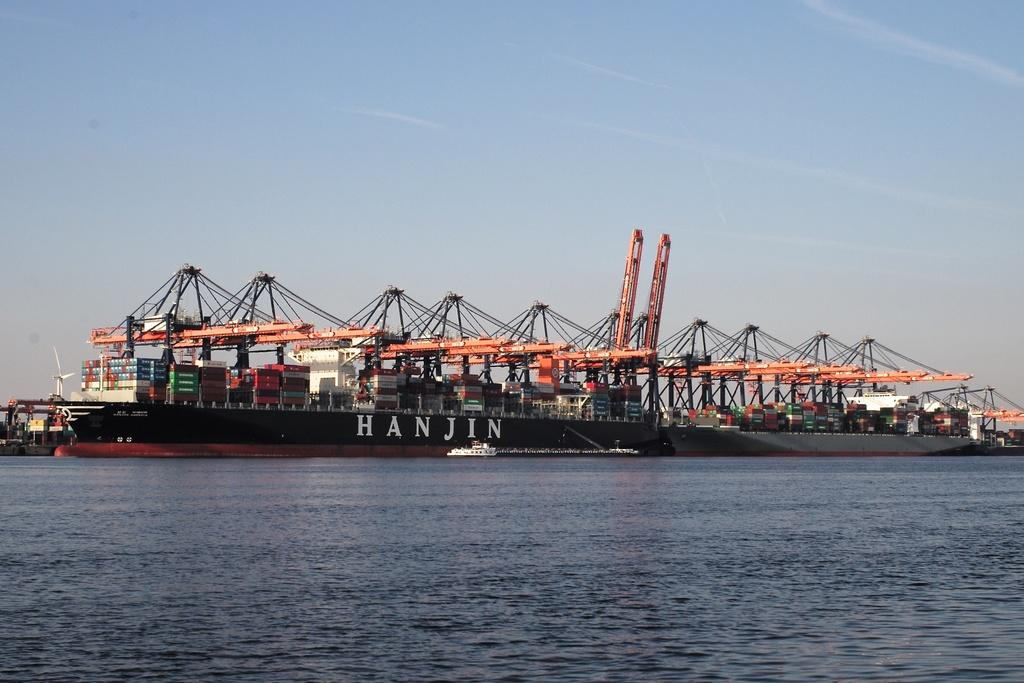<image>
Offer a succinct explanation of the picture presented. A small white boat is near the big ship called HANJIN. 